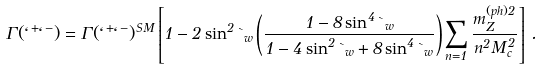Convert formula to latex. <formula><loc_0><loc_0><loc_500><loc_500>\Gamma ( \ell ^ { + } \ell ^ { - } ) = \Gamma ( \ell ^ { + } \ell ^ { - } ) ^ { S M } \left [ 1 - 2 \sin ^ { 2 } \theta _ { w } \left ( \frac { 1 - 8 \sin ^ { 4 } \theta _ { w } } { 1 - 4 \sin ^ { 2 } \theta _ { w } + 8 \sin ^ { 4 } \theta _ { w } } \right ) \sum _ { n = 1 } \frac { m _ { Z } ^ { ( p h ) 2 } } { n ^ { 2 } M _ { c } ^ { 2 } } \right ] \, .</formula> 